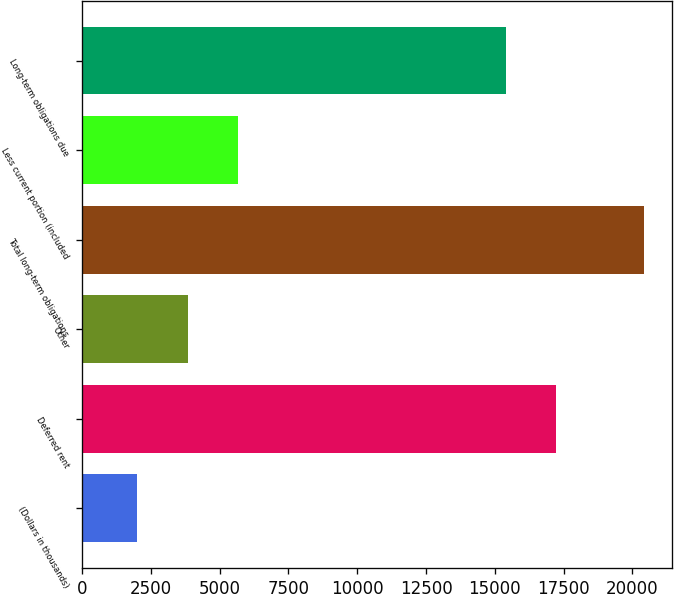Convert chart. <chart><loc_0><loc_0><loc_500><loc_500><bar_chart><fcel>(Dollars in thousands)<fcel>Deferred rent<fcel>Other<fcel>Total long-term obligations<fcel>Less current portion (included<fcel>Long-term obligations due<nl><fcel>2006<fcel>17239.8<fcel>3846.8<fcel>20414<fcel>5687.6<fcel>15399<nl></chart> 